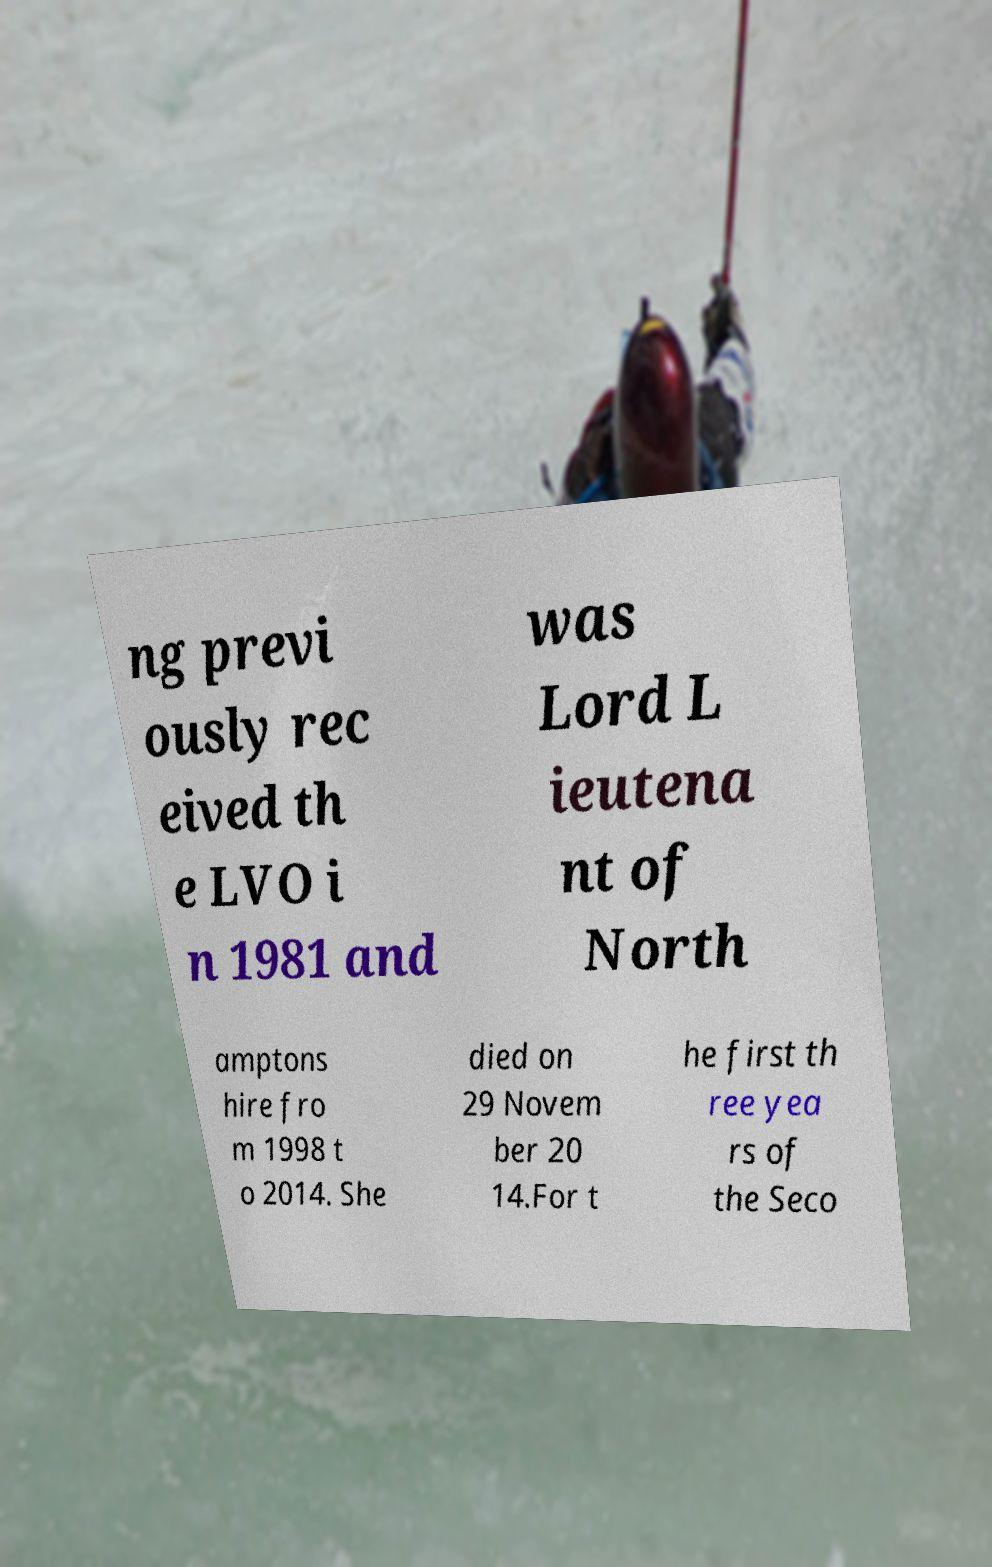There's text embedded in this image that I need extracted. Can you transcribe it verbatim? ng previ ously rec eived th e LVO i n 1981 and was Lord L ieutena nt of North amptons hire fro m 1998 t o 2014. She died on 29 Novem ber 20 14.For t he first th ree yea rs of the Seco 